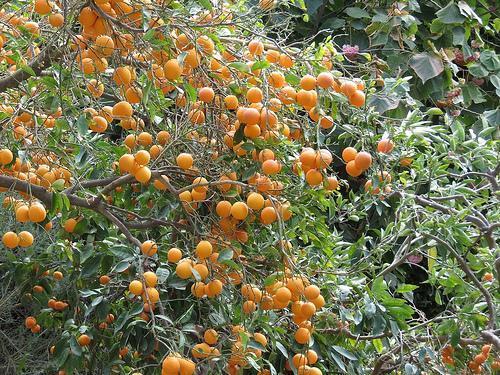How many people are eating orange?
Give a very brief answer. 0. 